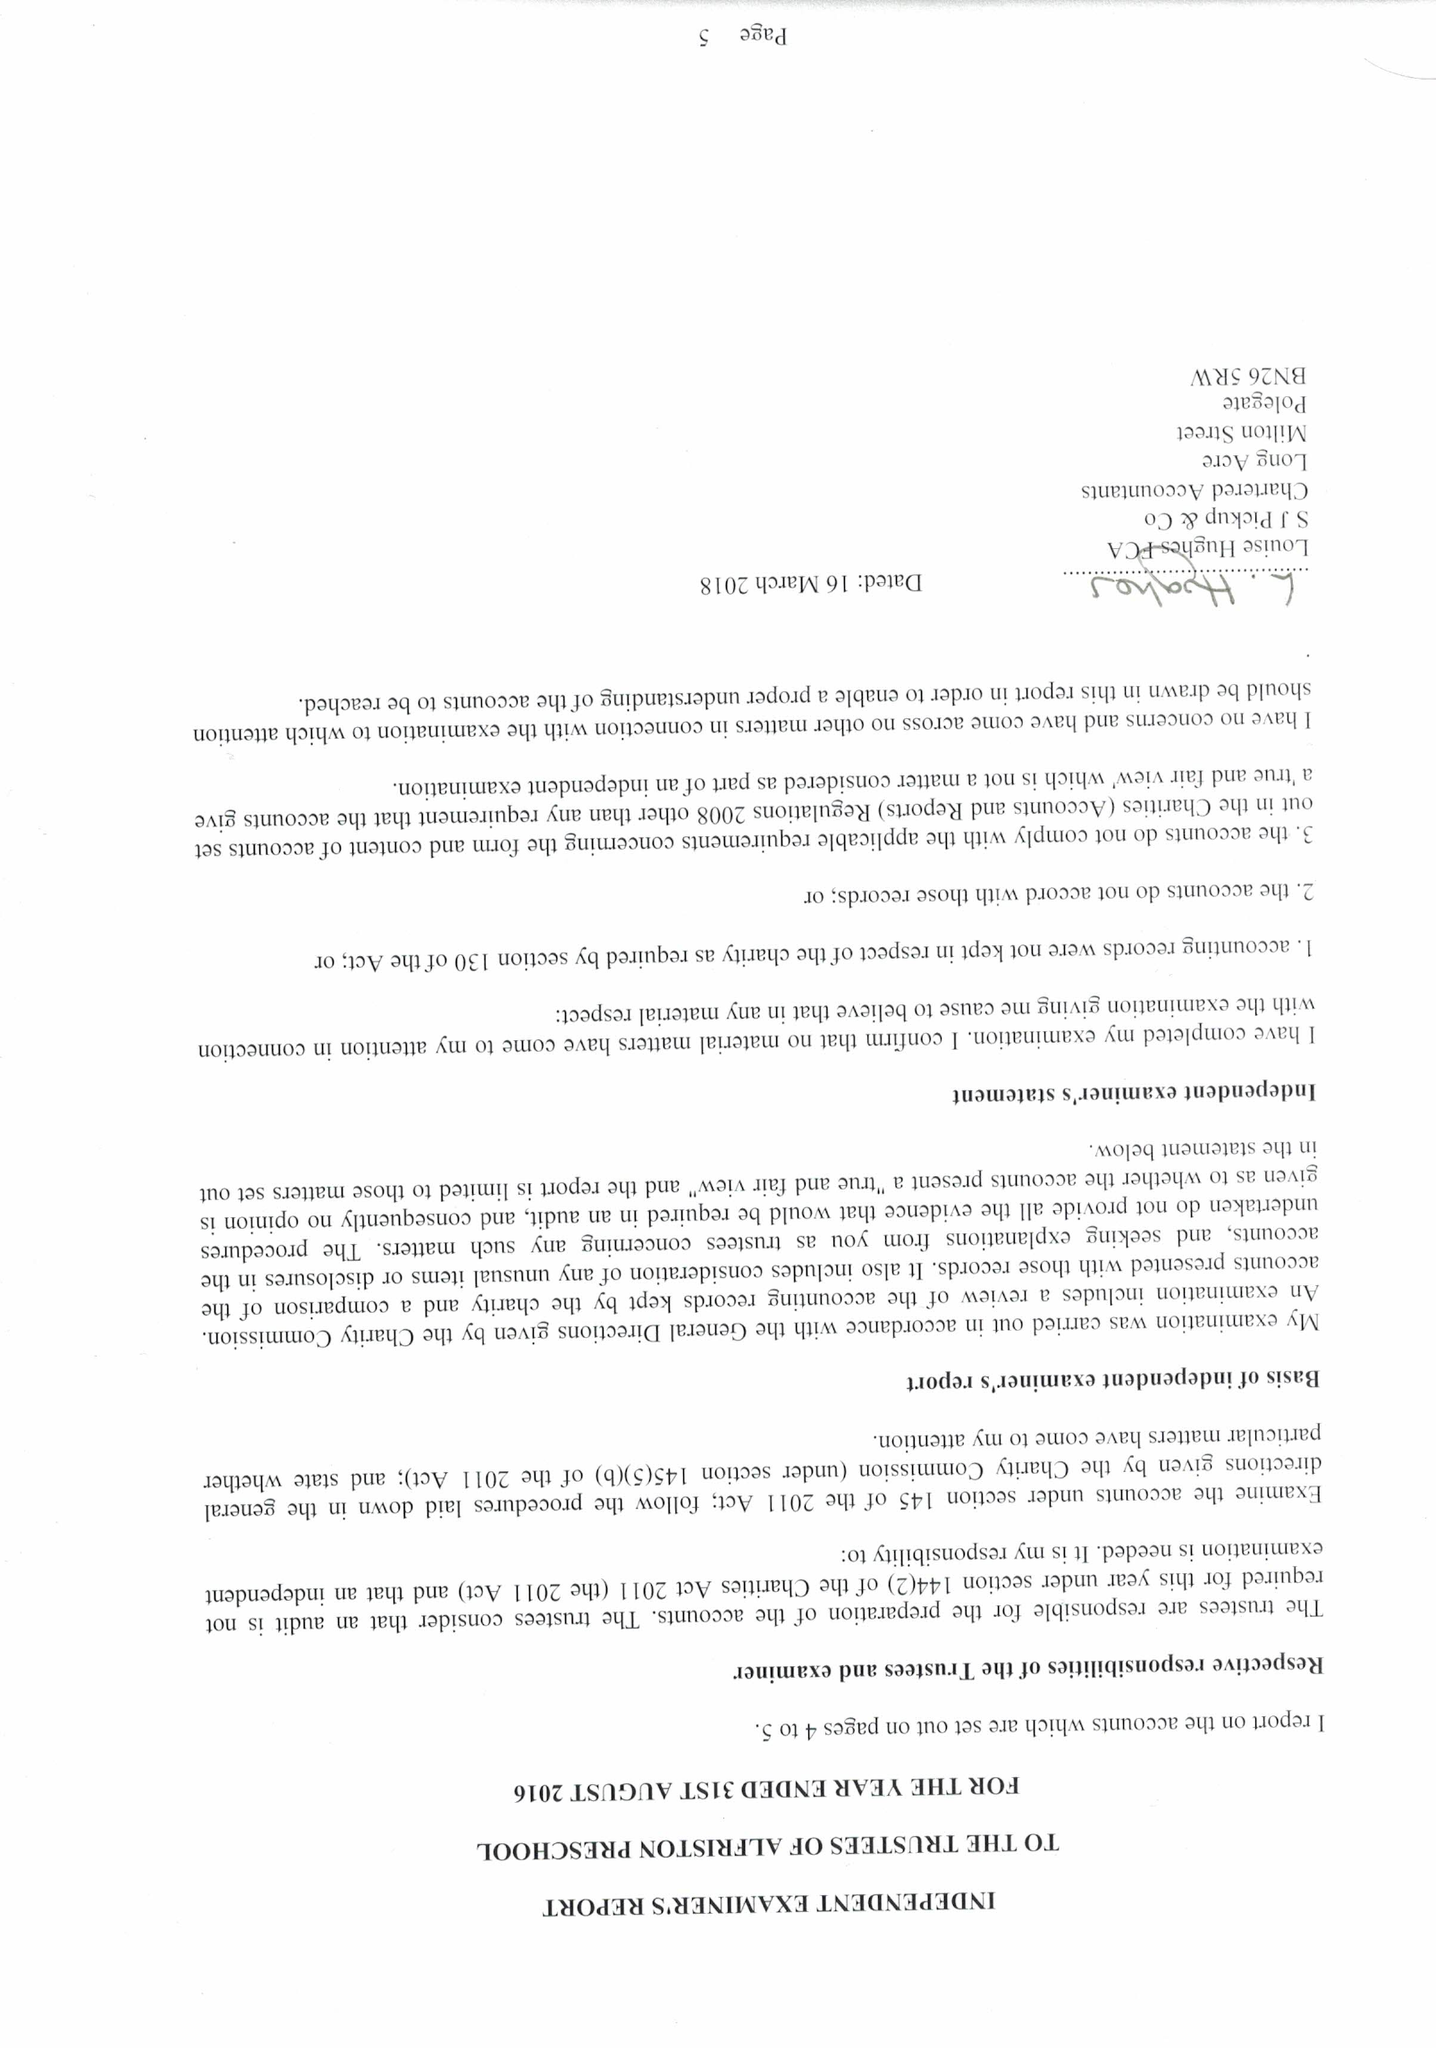What is the value for the address__postcode?
Answer the question using a single word or phrase. BN26 5TL 